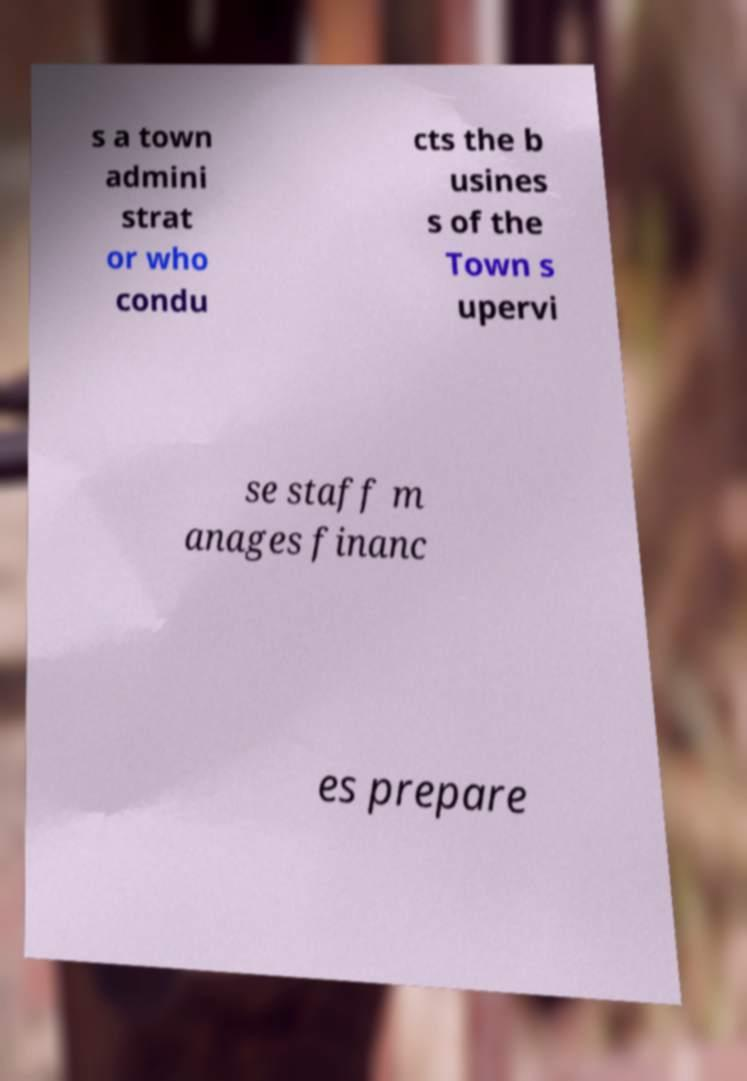Can you accurately transcribe the text from the provided image for me? s a town admini strat or who condu cts the b usines s of the Town s upervi se staff m anages financ es prepare 